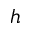Convert formula to latex. <formula><loc_0><loc_0><loc_500><loc_500>h</formula> 